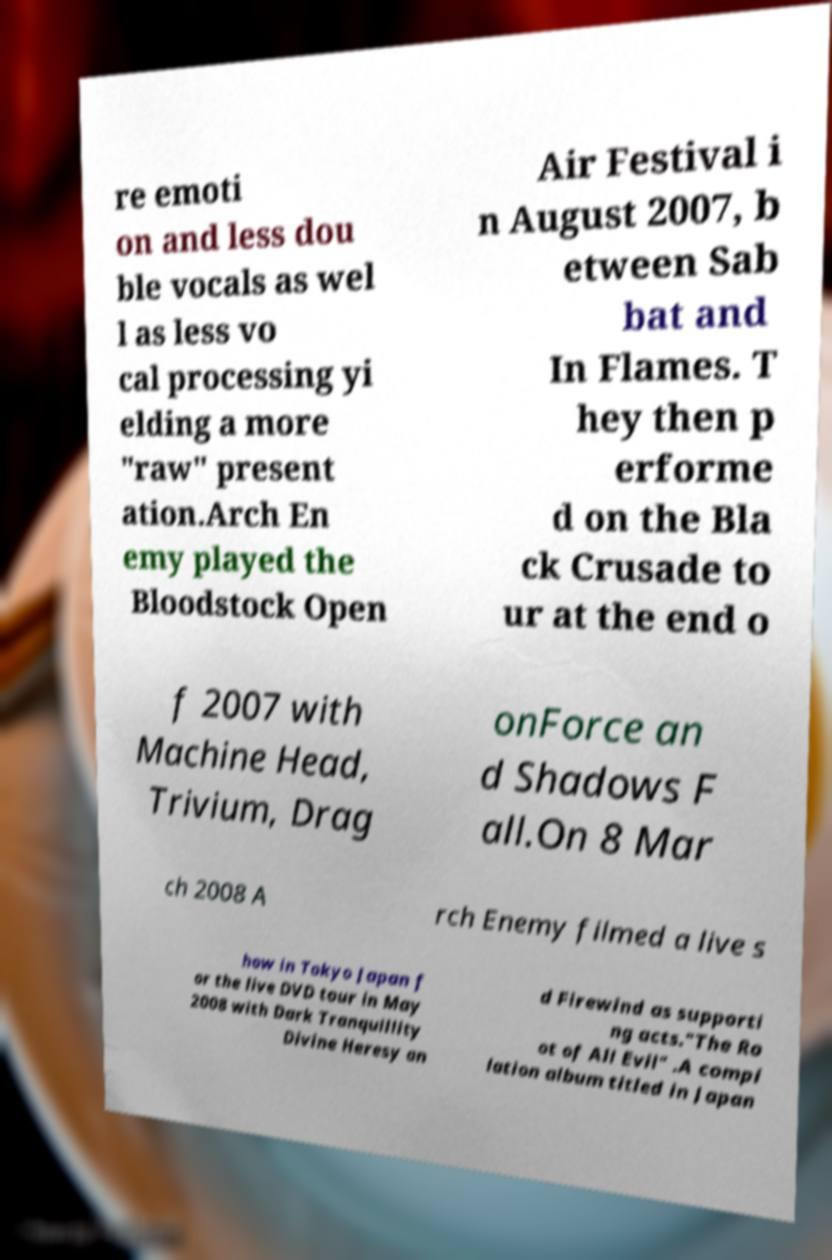What messages or text are displayed in this image? I need them in a readable, typed format. re emoti on and less dou ble vocals as wel l as less vo cal processing yi elding a more "raw" present ation.Arch En emy played the Bloodstock Open Air Festival i n August 2007, b etween Sab bat and In Flames. T hey then p erforme d on the Bla ck Crusade to ur at the end o f 2007 with Machine Head, Trivium, Drag onForce an d Shadows F all.On 8 Mar ch 2008 A rch Enemy filmed a live s how in Tokyo Japan f or the live DVD tour in May 2008 with Dark Tranquillity Divine Heresy an d Firewind as supporti ng acts."The Ro ot of All Evil" .A compi lation album titled in Japan 